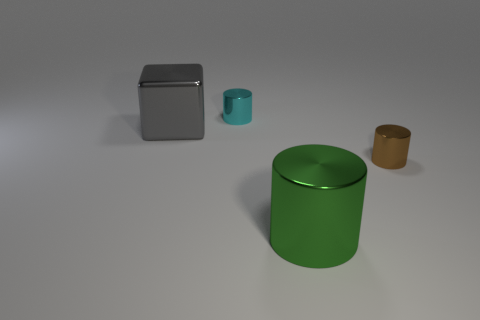What is the shape of the gray object?
Ensure brevity in your answer.  Cube. Are there fewer big gray shiny cubes than big brown metal cubes?
Ensure brevity in your answer.  No. Is there anything else that has the same size as the cyan thing?
Your response must be concise. Yes. There is a small brown thing that is the same shape as the cyan metallic object; what is its material?
Your answer should be compact. Metal. Is the number of small yellow objects greater than the number of brown metal things?
Provide a short and direct response. No. Is the large cylinder made of the same material as the cylinder that is behind the tiny brown cylinder?
Make the answer very short. Yes. What number of metallic cylinders are behind the big metal thing right of the tiny object on the left side of the brown object?
Your response must be concise. 2. Is the number of green shiny cylinders left of the green shiny thing less than the number of brown metallic cylinders in front of the large shiny block?
Keep it short and to the point. Yes. What number of other objects are there of the same material as the tiny cyan cylinder?
Provide a succinct answer. 3. What material is the thing that is the same size as the gray block?
Offer a terse response. Metal. 